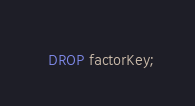Convert code to text. <code><loc_0><loc_0><loc_500><loc_500><_SQL_>  DROP factorKey;
</code> 